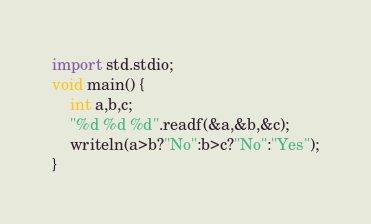<code> <loc_0><loc_0><loc_500><loc_500><_D_>import std.stdio;
void main() {
	int a,b,c;
	"%d %d %d".readf(&a,&b,&c);
	writeln(a>b?"No":b>c?"No":"Yes");
}</code> 